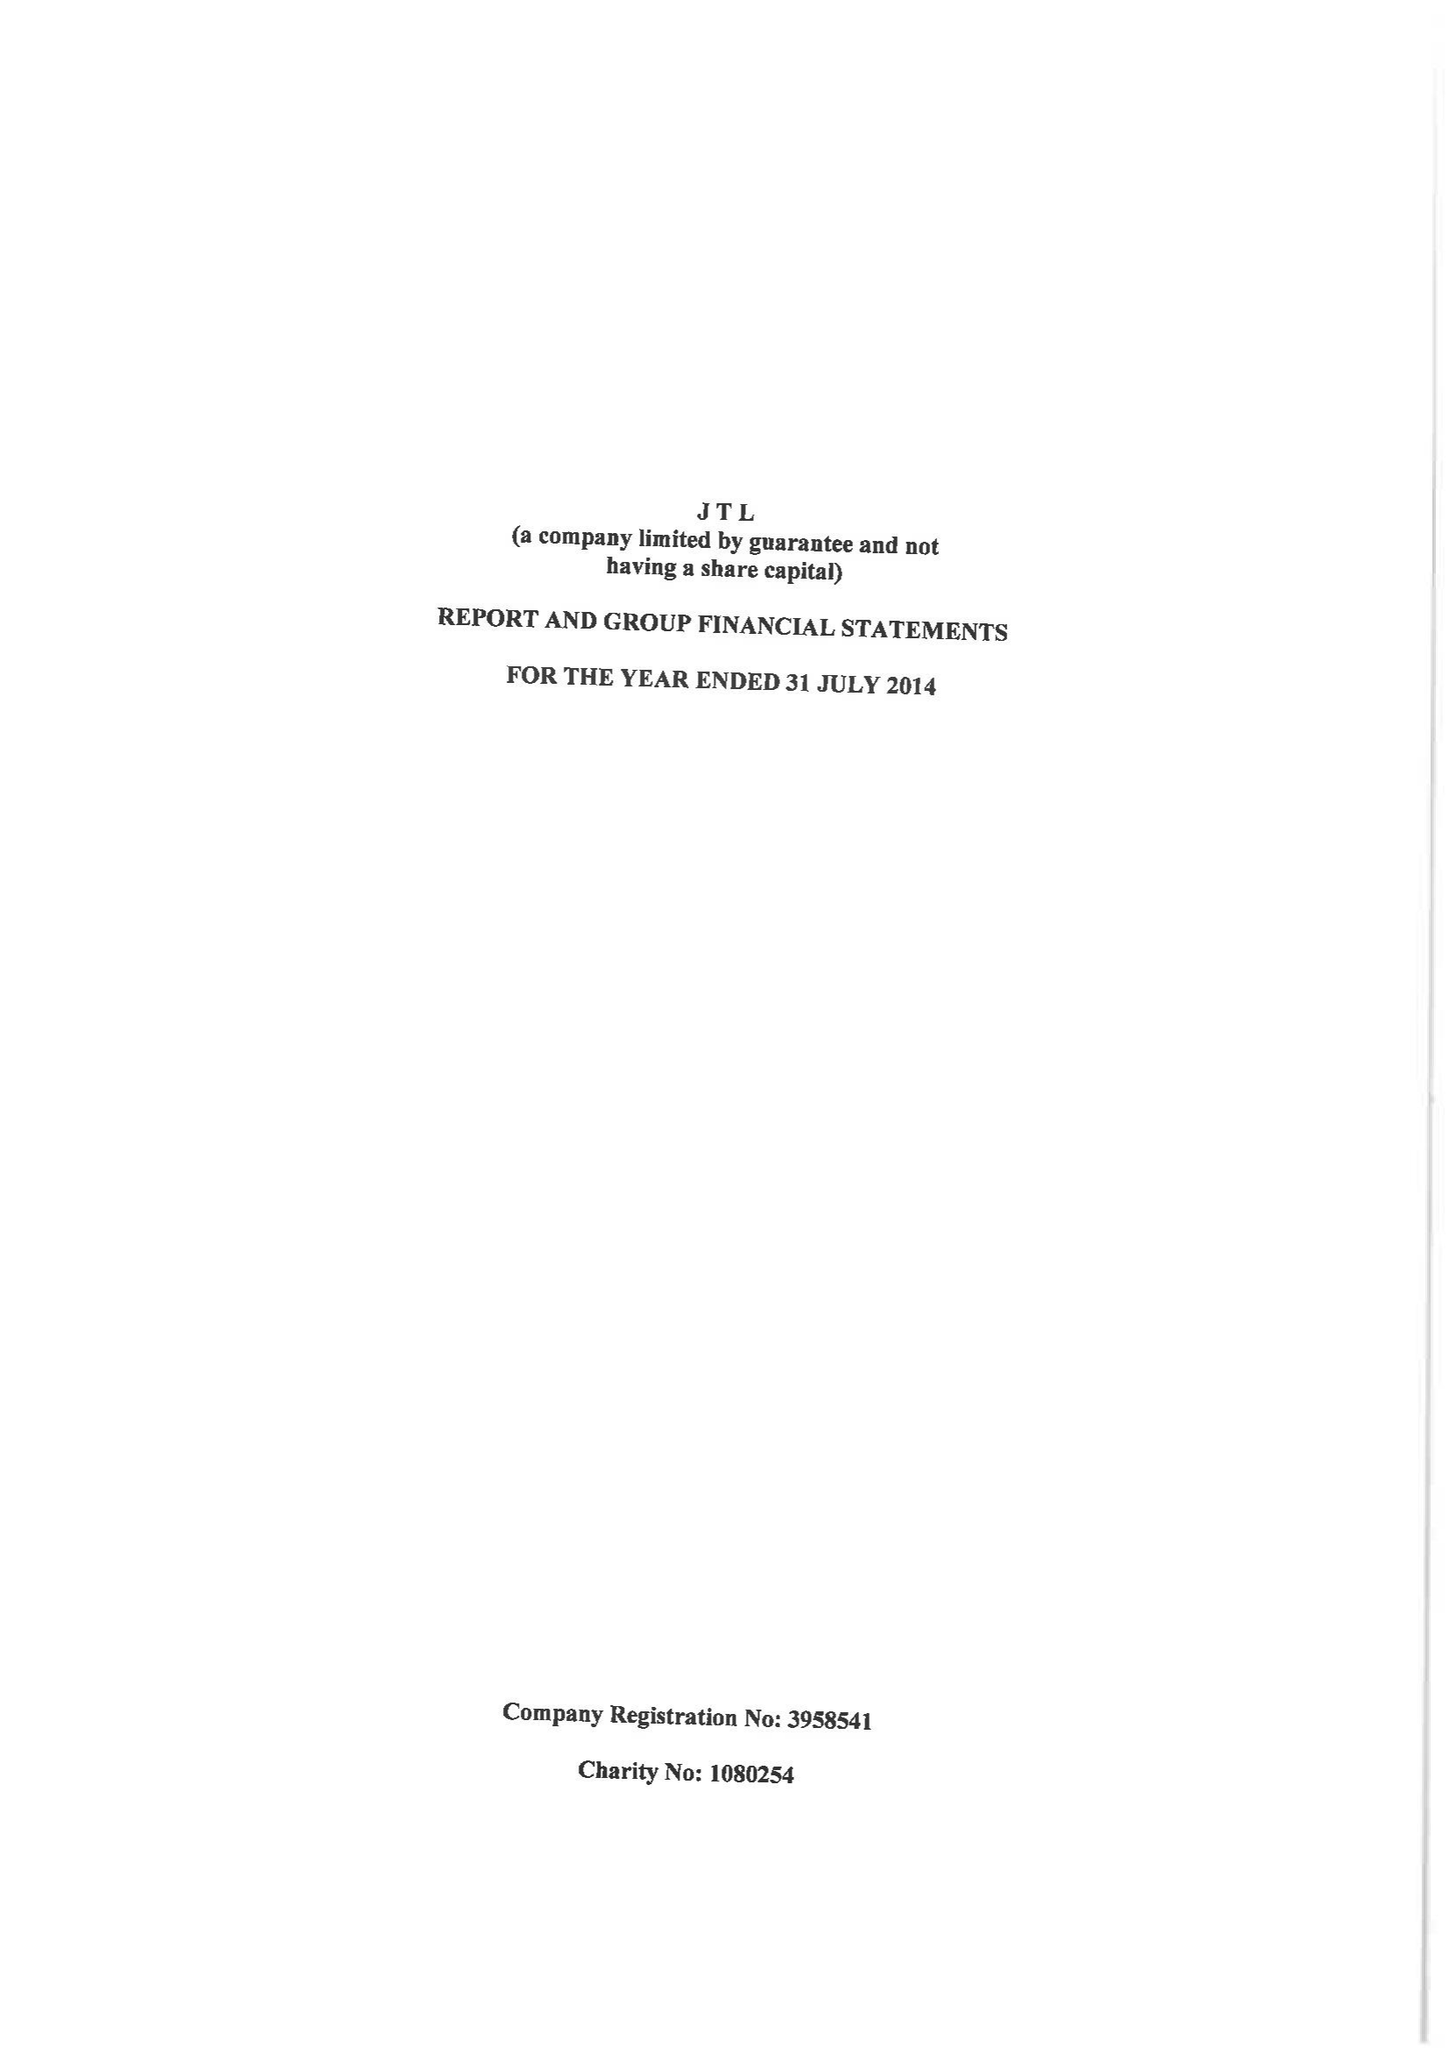What is the value for the charity_number?
Answer the question using a single word or phrase. 1080254 